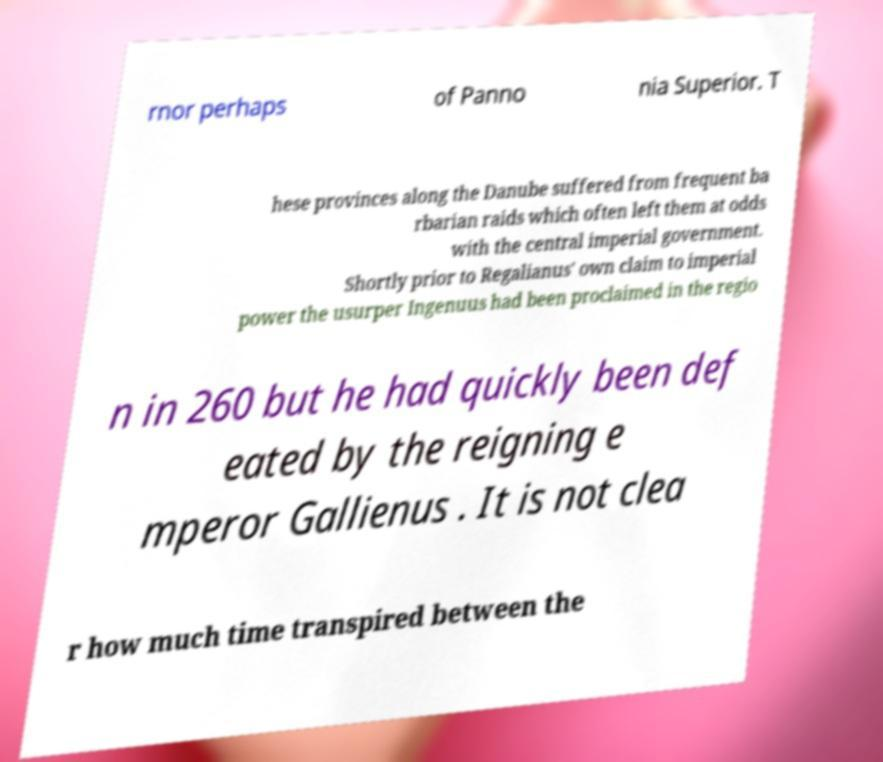For documentation purposes, I need the text within this image transcribed. Could you provide that? rnor perhaps of Panno nia Superior. T hese provinces along the Danube suffered from frequent ba rbarian raids which often left them at odds with the central imperial government. Shortly prior to Regalianus' own claim to imperial power the usurper Ingenuus had been proclaimed in the regio n in 260 but he had quickly been def eated by the reigning e mperor Gallienus . It is not clea r how much time transpired between the 